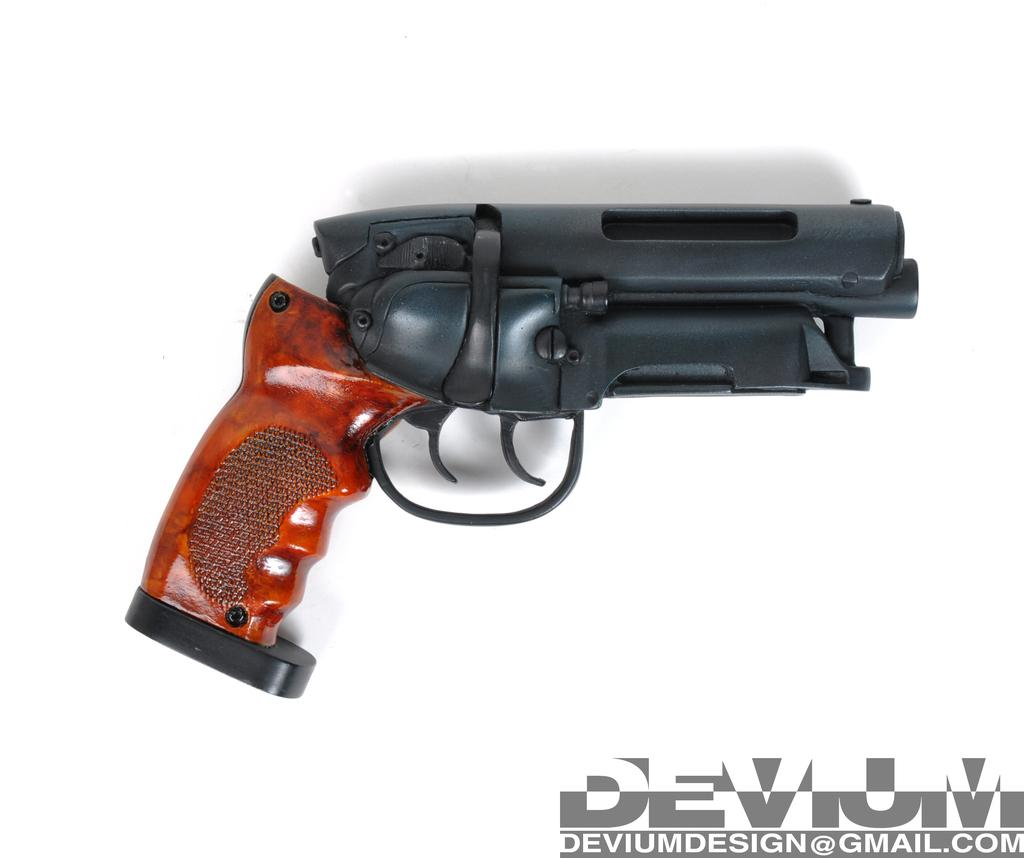What object is the main subject of the image? There is a gun in the image. Can you describe the appearance of the gun? The gun is black and brown in color. What is the color of the background in the image? The background of the image is white. How many boys are holding snakes in the image? There are no boys or snakes present in the image; it features a gun with a black and brown color scheme against a white background. What type of pickle is visible on the gun in the image? There is no pickle present in the image; it only features a gun with a black and brown color scheme against a white background. 